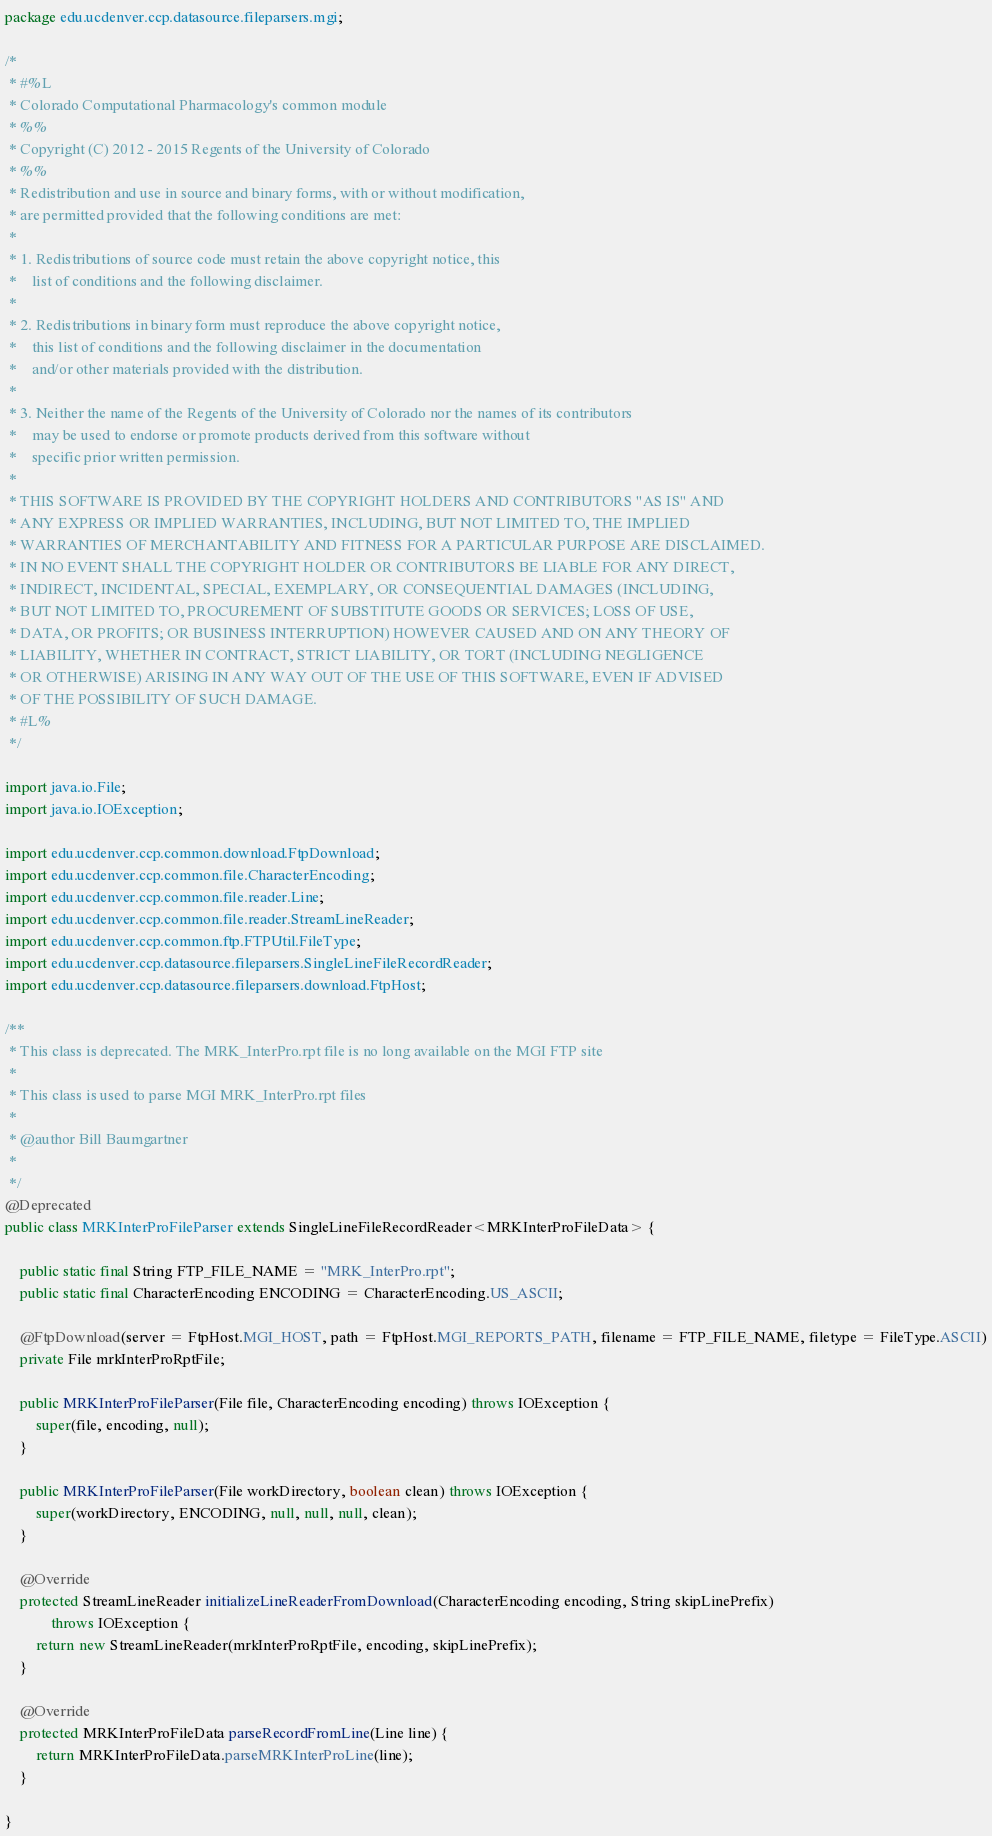<code> <loc_0><loc_0><loc_500><loc_500><_Java_>package edu.ucdenver.ccp.datasource.fileparsers.mgi;

/*
 * #%L
 * Colorado Computational Pharmacology's common module
 * %%
 * Copyright (C) 2012 - 2015 Regents of the University of Colorado
 * %%
 * Redistribution and use in source and binary forms, with or without modification,
 * are permitted provided that the following conditions are met:
 * 
 * 1. Redistributions of source code must retain the above copyright notice, this
 *    list of conditions and the following disclaimer.
 * 
 * 2. Redistributions in binary form must reproduce the above copyright notice,
 *    this list of conditions and the following disclaimer in the documentation
 *    and/or other materials provided with the distribution.
 * 
 * 3. Neither the name of the Regents of the University of Colorado nor the names of its contributors
 *    may be used to endorse or promote products derived from this software without
 *    specific prior written permission.
 * 
 * THIS SOFTWARE IS PROVIDED BY THE COPYRIGHT HOLDERS AND CONTRIBUTORS "AS IS" AND
 * ANY EXPRESS OR IMPLIED WARRANTIES, INCLUDING, BUT NOT LIMITED TO, THE IMPLIED
 * WARRANTIES OF MERCHANTABILITY AND FITNESS FOR A PARTICULAR PURPOSE ARE DISCLAIMED.
 * IN NO EVENT SHALL THE COPYRIGHT HOLDER OR CONTRIBUTORS BE LIABLE FOR ANY DIRECT,
 * INDIRECT, INCIDENTAL, SPECIAL, EXEMPLARY, OR CONSEQUENTIAL DAMAGES (INCLUDING,
 * BUT NOT LIMITED TO, PROCUREMENT OF SUBSTITUTE GOODS OR SERVICES; LOSS OF USE,
 * DATA, OR PROFITS; OR BUSINESS INTERRUPTION) HOWEVER CAUSED AND ON ANY THEORY OF
 * LIABILITY, WHETHER IN CONTRACT, STRICT LIABILITY, OR TORT (INCLUDING NEGLIGENCE
 * OR OTHERWISE) ARISING IN ANY WAY OUT OF THE USE OF THIS SOFTWARE, EVEN IF ADVISED
 * OF THE POSSIBILITY OF SUCH DAMAGE.
 * #L%
 */

import java.io.File;
import java.io.IOException;

import edu.ucdenver.ccp.common.download.FtpDownload;
import edu.ucdenver.ccp.common.file.CharacterEncoding;
import edu.ucdenver.ccp.common.file.reader.Line;
import edu.ucdenver.ccp.common.file.reader.StreamLineReader;
import edu.ucdenver.ccp.common.ftp.FTPUtil.FileType;
import edu.ucdenver.ccp.datasource.fileparsers.SingleLineFileRecordReader;
import edu.ucdenver.ccp.datasource.fileparsers.download.FtpHost;

/**
 * This class is deprecated. The MRK_InterPro.rpt file is no long available on the MGI FTP site
 * 
 * This class is used to parse MGI MRK_InterPro.rpt files
 * 
 * @author Bill Baumgartner
 * 
 */
@Deprecated
public class MRKInterProFileParser extends SingleLineFileRecordReader<MRKInterProFileData> {

	public static final String FTP_FILE_NAME = "MRK_InterPro.rpt";
	public static final CharacterEncoding ENCODING = CharacterEncoding.US_ASCII;

	@FtpDownload(server = FtpHost.MGI_HOST, path = FtpHost.MGI_REPORTS_PATH, filename = FTP_FILE_NAME, filetype = FileType.ASCII)
	private File mrkInterProRptFile;

	public MRKInterProFileParser(File file, CharacterEncoding encoding) throws IOException {
		super(file, encoding, null);
	}

	public MRKInterProFileParser(File workDirectory, boolean clean) throws IOException {
		super(workDirectory, ENCODING, null, null, null, clean);
	}

	@Override
	protected StreamLineReader initializeLineReaderFromDownload(CharacterEncoding encoding, String skipLinePrefix)
			throws IOException {
		return new StreamLineReader(mrkInterProRptFile, encoding, skipLinePrefix);
	}

	@Override
	protected MRKInterProFileData parseRecordFromLine(Line line) {
		return MRKInterProFileData.parseMRKInterProLine(line);
	}

}
</code> 